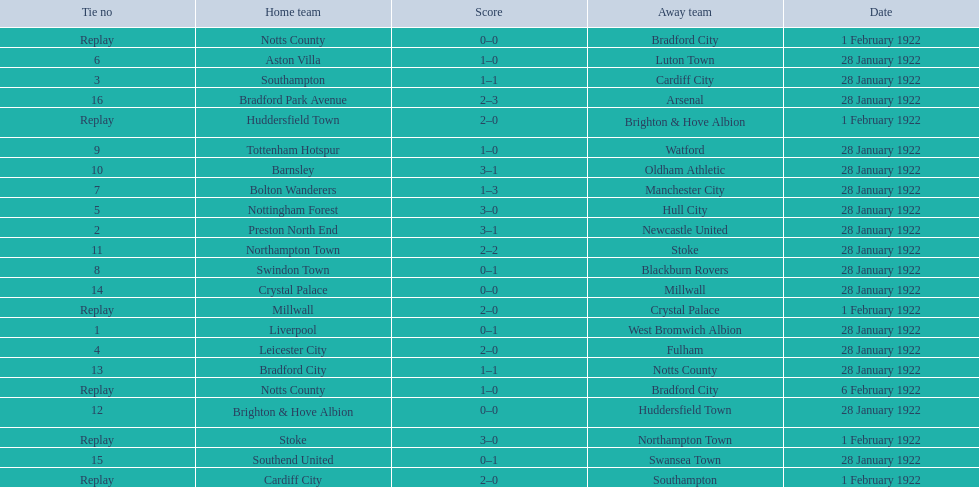How many games had no points scored? 3. 